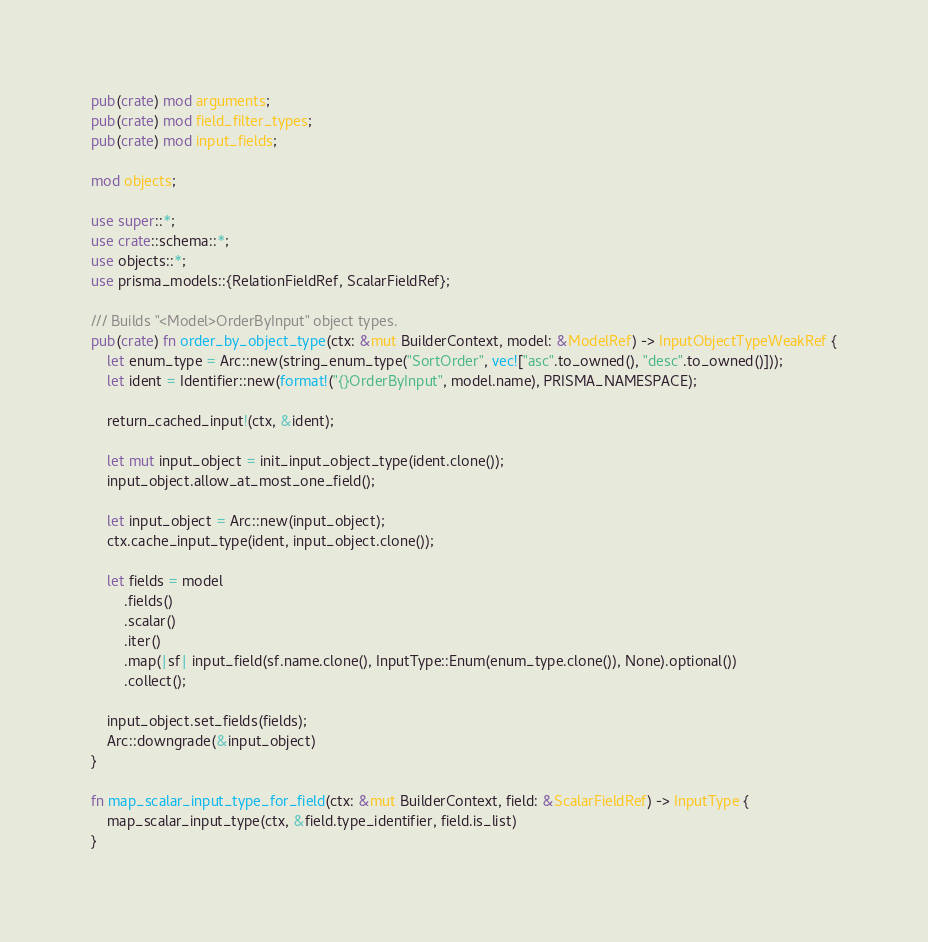Convert code to text. <code><loc_0><loc_0><loc_500><loc_500><_Rust_>pub(crate) mod arguments;
pub(crate) mod field_filter_types;
pub(crate) mod input_fields;

mod objects;

use super::*;
use crate::schema::*;
use objects::*;
use prisma_models::{RelationFieldRef, ScalarFieldRef};

/// Builds "<Model>OrderByInput" object types.
pub(crate) fn order_by_object_type(ctx: &mut BuilderContext, model: &ModelRef) -> InputObjectTypeWeakRef {
    let enum_type = Arc::new(string_enum_type("SortOrder", vec!["asc".to_owned(), "desc".to_owned()]));
    let ident = Identifier::new(format!("{}OrderByInput", model.name), PRISMA_NAMESPACE);

    return_cached_input!(ctx, &ident);

    let mut input_object = init_input_object_type(ident.clone());
    input_object.allow_at_most_one_field();

    let input_object = Arc::new(input_object);
    ctx.cache_input_type(ident, input_object.clone());

    let fields = model
        .fields()
        .scalar()
        .iter()
        .map(|sf| input_field(sf.name.clone(), InputType::Enum(enum_type.clone()), None).optional())
        .collect();

    input_object.set_fields(fields);
    Arc::downgrade(&input_object)
}

fn map_scalar_input_type_for_field(ctx: &mut BuilderContext, field: &ScalarFieldRef) -> InputType {
    map_scalar_input_type(ctx, &field.type_identifier, field.is_list)
}
</code> 